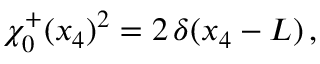Convert formula to latex. <formula><loc_0><loc_0><loc_500><loc_500>\chi _ { 0 } ^ { + } ( x _ { 4 } ) ^ { 2 } = 2 \, \delta ( x _ { 4 } - L ) \, ,</formula> 